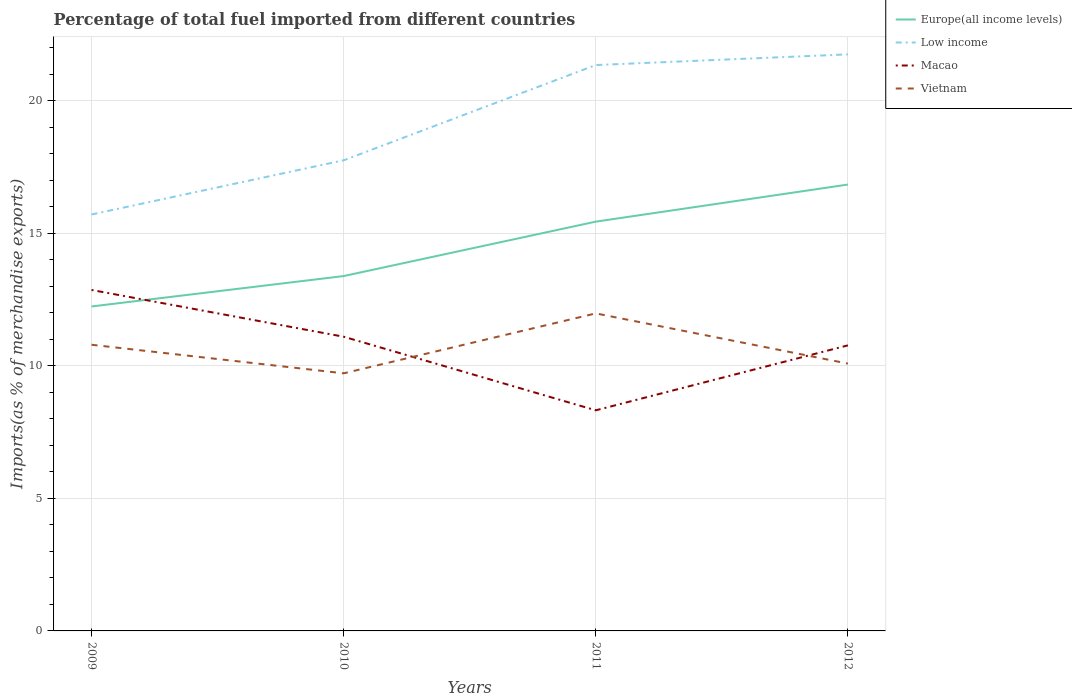Across all years, what is the maximum percentage of imports to different countries in Low income?
Provide a succinct answer. 15.72. What is the total percentage of imports to different countries in Europe(all income levels) in the graph?
Your response must be concise. -3.45. What is the difference between the highest and the second highest percentage of imports to different countries in Macao?
Provide a succinct answer. 4.54. What is the difference between the highest and the lowest percentage of imports to different countries in Vietnam?
Make the answer very short. 2. Is the percentage of imports to different countries in Macao strictly greater than the percentage of imports to different countries in Low income over the years?
Provide a short and direct response. Yes. Does the graph contain grids?
Make the answer very short. Yes. How many legend labels are there?
Give a very brief answer. 4. How are the legend labels stacked?
Make the answer very short. Vertical. What is the title of the graph?
Your response must be concise. Percentage of total fuel imported from different countries. What is the label or title of the Y-axis?
Keep it short and to the point. Imports(as % of merchandise exports). What is the Imports(as % of merchandise exports) of Europe(all income levels) in 2009?
Your answer should be very brief. 12.24. What is the Imports(as % of merchandise exports) of Low income in 2009?
Ensure brevity in your answer.  15.72. What is the Imports(as % of merchandise exports) of Macao in 2009?
Make the answer very short. 12.87. What is the Imports(as % of merchandise exports) in Vietnam in 2009?
Your answer should be compact. 10.8. What is the Imports(as % of merchandise exports) of Europe(all income levels) in 2010?
Provide a succinct answer. 13.39. What is the Imports(as % of merchandise exports) in Low income in 2010?
Your response must be concise. 17.76. What is the Imports(as % of merchandise exports) in Macao in 2010?
Offer a very short reply. 11.1. What is the Imports(as % of merchandise exports) of Vietnam in 2010?
Your response must be concise. 9.72. What is the Imports(as % of merchandise exports) of Europe(all income levels) in 2011?
Offer a terse response. 15.45. What is the Imports(as % of merchandise exports) in Low income in 2011?
Give a very brief answer. 21.36. What is the Imports(as % of merchandise exports) in Macao in 2011?
Ensure brevity in your answer.  8.33. What is the Imports(as % of merchandise exports) of Vietnam in 2011?
Keep it short and to the point. 11.98. What is the Imports(as % of merchandise exports) in Europe(all income levels) in 2012?
Offer a very short reply. 16.85. What is the Imports(as % of merchandise exports) of Low income in 2012?
Your response must be concise. 21.76. What is the Imports(as % of merchandise exports) of Macao in 2012?
Make the answer very short. 10.78. What is the Imports(as % of merchandise exports) of Vietnam in 2012?
Keep it short and to the point. 10.09. Across all years, what is the maximum Imports(as % of merchandise exports) in Europe(all income levels)?
Offer a terse response. 16.85. Across all years, what is the maximum Imports(as % of merchandise exports) of Low income?
Your answer should be compact. 21.76. Across all years, what is the maximum Imports(as % of merchandise exports) of Macao?
Offer a terse response. 12.87. Across all years, what is the maximum Imports(as % of merchandise exports) of Vietnam?
Make the answer very short. 11.98. Across all years, what is the minimum Imports(as % of merchandise exports) in Europe(all income levels)?
Provide a succinct answer. 12.24. Across all years, what is the minimum Imports(as % of merchandise exports) in Low income?
Provide a succinct answer. 15.72. Across all years, what is the minimum Imports(as % of merchandise exports) in Macao?
Give a very brief answer. 8.33. Across all years, what is the minimum Imports(as % of merchandise exports) in Vietnam?
Provide a succinct answer. 9.72. What is the total Imports(as % of merchandise exports) in Europe(all income levels) in the graph?
Ensure brevity in your answer.  57.93. What is the total Imports(as % of merchandise exports) in Low income in the graph?
Give a very brief answer. 76.59. What is the total Imports(as % of merchandise exports) in Macao in the graph?
Your answer should be very brief. 43.07. What is the total Imports(as % of merchandise exports) in Vietnam in the graph?
Provide a succinct answer. 42.59. What is the difference between the Imports(as % of merchandise exports) in Europe(all income levels) in 2009 and that in 2010?
Your response must be concise. -1.15. What is the difference between the Imports(as % of merchandise exports) in Low income in 2009 and that in 2010?
Provide a short and direct response. -2.04. What is the difference between the Imports(as % of merchandise exports) in Macao in 2009 and that in 2010?
Give a very brief answer. 1.76. What is the difference between the Imports(as % of merchandise exports) in Vietnam in 2009 and that in 2010?
Your answer should be very brief. 1.08. What is the difference between the Imports(as % of merchandise exports) of Europe(all income levels) in 2009 and that in 2011?
Offer a very short reply. -3.2. What is the difference between the Imports(as % of merchandise exports) in Low income in 2009 and that in 2011?
Give a very brief answer. -5.64. What is the difference between the Imports(as % of merchandise exports) in Macao in 2009 and that in 2011?
Provide a succinct answer. 4.54. What is the difference between the Imports(as % of merchandise exports) of Vietnam in 2009 and that in 2011?
Ensure brevity in your answer.  -1.18. What is the difference between the Imports(as % of merchandise exports) of Europe(all income levels) in 2009 and that in 2012?
Ensure brevity in your answer.  -4.6. What is the difference between the Imports(as % of merchandise exports) of Low income in 2009 and that in 2012?
Provide a short and direct response. -6.04. What is the difference between the Imports(as % of merchandise exports) of Macao in 2009 and that in 2012?
Your answer should be very brief. 2.09. What is the difference between the Imports(as % of merchandise exports) of Vietnam in 2009 and that in 2012?
Your response must be concise. 0.71. What is the difference between the Imports(as % of merchandise exports) of Europe(all income levels) in 2010 and that in 2011?
Make the answer very short. -2.05. What is the difference between the Imports(as % of merchandise exports) in Low income in 2010 and that in 2011?
Provide a short and direct response. -3.59. What is the difference between the Imports(as % of merchandise exports) of Macao in 2010 and that in 2011?
Provide a short and direct response. 2.78. What is the difference between the Imports(as % of merchandise exports) in Vietnam in 2010 and that in 2011?
Ensure brevity in your answer.  -2.26. What is the difference between the Imports(as % of merchandise exports) of Europe(all income levels) in 2010 and that in 2012?
Provide a succinct answer. -3.45. What is the difference between the Imports(as % of merchandise exports) in Low income in 2010 and that in 2012?
Give a very brief answer. -4. What is the difference between the Imports(as % of merchandise exports) of Macao in 2010 and that in 2012?
Your answer should be very brief. 0.33. What is the difference between the Imports(as % of merchandise exports) in Vietnam in 2010 and that in 2012?
Make the answer very short. -0.37. What is the difference between the Imports(as % of merchandise exports) in Europe(all income levels) in 2011 and that in 2012?
Provide a short and direct response. -1.4. What is the difference between the Imports(as % of merchandise exports) of Low income in 2011 and that in 2012?
Your answer should be very brief. -0.4. What is the difference between the Imports(as % of merchandise exports) of Macao in 2011 and that in 2012?
Give a very brief answer. -2.45. What is the difference between the Imports(as % of merchandise exports) of Vietnam in 2011 and that in 2012?
Provide a succinct answer. 1.89. What is the difference between the Imports(as % of merchandise exports) in Europe(all income levels) in 2009 and the Imports(as % of merchandise exports) in Low income in 2010?
Your answer should be compact. -5.52. What is the difference between the Imports(as % of merchandise exports) of Europe(all income levels) in 2009 and the Imports(as % of merchandise exports) of Macao in 2010?
Offer a terse response. 1.14. What is the difference between the Imports(as % of merchandise exports) in Europe(all income levels) in 2009 and the Imports(as % of merchandise exports) in Vietnam in 2010?
Offer a terse response. 2.52. What is the difference between the Imports(as % of merchandise exports) in Low income in 2009 and the Imports(as % of merchandise exports) in Macao in 2010?
Keep it short and to the point. 4.61. What is the difference between the Imports(as % of merchandise exports) of Low income in 2009 and the Imports(as % of merchandise exports) of Vietnam in 2010?
Provide a short and direct response. 5.99. What is the difference between the Imports(as % of merchandise exports) of Macao in 2009 and the Imports(as % of merchandise exports) of Vietnam in 2010?
Your answer should be very brief. 3.15. What is the difference between the Imports(as % of merchandise exports) in Europe(all income levels) in 2009 and the Imports(as % of merchandise exports) in Low income in 2011?
Make the answer very short. -9.11. What is the difference between the Imports(as % of merchandise exports) in Europe(all income levels) in 2009 and the Imports(as % of merchandise exports) in Macao in 2011?
Your answer should be very brief. 3.92. What is the difference between the Imports(as % of merchandise exports) in Europe(all income levels) in 2009 and the Imports(as % of merchandise exports) in Vietnam in 2011?
Your response must be concise. 0.26. What is the difference between the Imports(as % of merchandise exports) of Low income in 2009 and the Imports(as % of merchandise exports) of Macao in 2011?
Provide a short and direct response. 7.39. What is the difference between the Imports(as % of merchandise exports) of Low income in 2009 and the Imports(as % of merchandise exports) of Vietnam in 2011?
Your answer should be very brief. 3.73. What is the difference between the Imports(as % of merchandise exports) in Macao in 2009 and the Imports(as % of merchandise exports) in Vietnam in 2011?
Your answer should be compact. 0.88. What is the difference between the Imports(as % of merchandise exports) in Europe(all income levels) in 2009 and the Imports(as % of merchandise exports) in Low income in 2012?
Your answer should be very brief. -9.51. What is the difference between the Imports(as % of merchandise exports) in Europe(all income levels) in 2009 and the Imports(as % of merchandise exports) in Macao in 2012?
Offer a terse response. 1.47. What is the difference between the Imports(as % of merchandise exports) of Europe(all income levels) in 2009 and the Imports(as % of merchandise exports) of Vietnam in 2012?
Offer a very short reply. 2.16. What is the difference between the Imports(as % of merchandise exports) in Low income in 2009 and the Imports(as % of merchandise exports) in Macao in 2012?
Offer a terse response. 4.94. What is the difference between the Imports(as % of merchandise exports) in Low income in 2009 and the Imports(as % of merchandise exports) in Vietnam in 2012?
Ensure brevity in your answer.  5.63. What is the difference between the Imports(as % of merchandise exports) of Macao in 2009 and the Imports(as % of merchandise exports) of Vietnam in 2012?
Provide a succinct answer. 2.78. What is the difference between the Imports(as % of merchandise exports) in Europe(all income levels) in 2010 and the Imports(as % of merchandise exports) in Low income in 2011?
Your response must be concise. -7.96. What is the difference between the Imports(as % of merchandise exports) of Europe(all income levels) in 2010 and the Imports(as % of merchandise exports) of Macao in 2011?
Your response must be concise. 5.07. What is the difference between the Imports(as % of merchandise exports) in Europe(all income levels) in 2010 and the Imports(as % of merchandise exports) in Vietnam in 2011?
Provide a short and direct response. 1.41. What is the difference between the Imports(as % of merchandise exports) of Low income in 2010 and the Imports(as % of merchandise exports) of Macao in 2011?
Keep it short and to the point. 9.44. What is the difference between the Imports(as % of merchandise exports) in Low income in 2010 and the Imports(as % of merchandise exports) in Vietnam in 2011?
Provide a succinct answer. 5.78. What is the difference between the Imports(as % of merchandise exports) in Macao in 2010 and the Imports(as % of merchandise exports) in Vietnam in 2011?
Your response must be concise. -0.88. What is the difference between the Imports(as % of merchandise exports) of Europe(all income levels) in 2010 and the Imports(as % of merchandise exports) of Low income in 2012?
Keep it short and to the point. -8.37. What is the difference between the Imports(as % of merchandise exports) of Europe(all income levels) in 2010 and the Imports(as % of merchandise exports) of Macao in 2012?
Ensure brevity in your answer.  2.62. What is the difference between the Imports(as % of merchandise exports) in Europe(all income levels) in 2010 and the Imports(as % of merchandise exports) in Vietnam in 2012?
Make the answer very short. 3.3. What is the difference between the Imports(as % of merchandise exports) in Low income in 2010 and the Imports(as % of merchandise exports) in Macao in 2012?
Your response must be concise. 6.98. What is the difference between the Imports(as % of merchandise exports) of Low income in 2010 and the Imports(as % of merchandise exports) of Vietnam in 2012?
Your response must be concise. 7.67. What is the difference between the Imports(as % of merchandise exports) in Macao in 2010 and the Imports(as % of merchandise exports) in Vietnam in 2012?
Provide a succinct answer. 1.01. What is the difference between the Imports(as % of merchandise exports) in Europe(all income levels) in 2011 and the Imports(as % of merchandise exports) in Low income in 2012?
Your answer should be very brief. -6.31. What is the difference between the Imports(as % of merchandise exports) of Europe(all income levels) in 2011 and the Imports(as % of merchandise exports) of Macao in 2012?
Provide a short and direct response. 4.67. What is the difference between the Imports(as % of merchandise exports) of Europe(all income levels) in 2011 and the Imports(as % of merchandise exports) of Vietnam in 2012?
Your answer should be very brief. 5.36. What is the difference between the Imports(as % of merchandise exports) of Low income in 2011 and the Imports(as % of merchandise exports) of Macao in 2012?
Provide a succinct answer. 10.58. What is the difference between the Imports(as % of merchandise exports) of Low income in 2011 and the Imports(as % of merchandise exports) of Vietnam in 2012?
Provide a succinct answer. 11.27. What is the difference between the Imports(as % of merchandise exports) of Macao in 2011 and the Imports(as % of merchandise exports) of Vietnam in 2012?
Give a very brief answer. -1.76. What is the average Imports(as % of merchandise exports) in Europe(all income levels) per year?
Provide a succinct answer. 14.48. What is the average Imports(as % of merchandise exports) in Low income per year?
Ensure brevity in your answer.  19.15. What is the average Imports(as % of merchandise exports) of Macao per year?
Your answer should be very brief. 10.77. What is the average Imports(as % of merchandise exports) of Vietnam per year?
Ensure brevity in your answer.  10.65. In the year 2009, what is the difference between the Imports(as % of merchandise exports) in Europe(all income levels) and Imports(as % of merchandise exports) in Low income?
Provide a short and direct response. -3.47. In the year 2009, what is the difference between the Imports(as % of merchandise exports) in Europe(all income levels) and Imports(as % of merchandise exports) in Macao?
Offer a very short reply. -0.62. In the year 2009, what is the difference between the Imports(as % of merchandise exports) in Europe(all income levels) and Imports(as % of merchandise exports) in Vietnam?
Offer a very short reply. 1.45. In the year 2009, what is the difference between the Imports(as % of merchandise exports) of Low income and Imports(as % of merchandise exports) of Macao?
Ensure brevity in your answer.  2.85. In the year 2009, what is the difference between the Imports(as % of merchandise exports) in Low income and Imports(as % of merchandise exports) in Vietnam?
Keep it short and to the point. 4.92. In the year 2009, what is the difference between the Imports(as % of merchandise exports) of Macao and Imports(as % of merchandise exports) of Vietnam?
Offer a terse response. 2.07. In the year 2010, what is the difference between the Imports(as % of merchandise exports) in Europe(all income levels) and Imports(as % of merchandise exports) in Low income?
Keep it short and to the point. -4.37. In the year 2010, what is the difference between the Imports(as % of merchandise exports) in Europe(all income levels) and Imports(as % of merchandise exports) in Macao?
Offer a very short reply. 2.29. In the year 2010, what is the difference between the Imports(as % of merchandise exports) in Europe(all income levels) and Imports(as % of merchandise exports) in Vietnam?
Offer a very short reply. 3.67. In the year 2010, what is the difference between the Imports(as % of merchandise exports) of Low income and Imports(as % of merchandise exports) of Macao?
Make the answer very short. 6.66. In the year 2010, what is the difference between the Imports(as % of merchandise exports) in Low income and Imports(as % of merchandise exports) in Vietnam?
Give a very brief answer. 8.04. In the year 2010, what is the difference between the Imports(as % of merchandise exports) in Macao and Imports(as % of merchandise exports) in Vietnam?
Ensure brevity in your answer.  1.38. In the year 2011, what is the difference between the Imports(as % of merchandise exports) of Europe(all income levels) and Imports(as % of merchandise exports) of Low income?
Provide a short and direct response. -5.91. In the year 2011, what is the difference between the Imports(as % of merchandise exports) in Europe(all income levels) and Imports(as % of merchandise exports) in Macao?
Your response must be concise. 7.12. In the year 2011, what is the difference between the Imports(as % of merchandise exports) of Europe(all income levels) and Imports(as % of merchandise exports) of Vietnam?
Provide a succinct answer. 3.46. In the year 2011, what is the difference between the Imports(as % of merchandise exports) of Low income and Imports(as % of merchandise exports) of Macao?
Keep it short and to the point. 13.03. In the year 2011, what is the difference between the Imports(as % of merchandise exports) in Low income and Imports(as % of merchandise exports) in Vietnam?
Make the answer very short. 9.37. In the year 2011, what is the difference between the Imports(as % of merchandise exports) of Macao and Imports(as % of merchandise exports) of Vietnam?
Ensure brevity in your answer.  -3.66. In the year 2012, what is the difference between the Imports(as % of merchandise exports) of Europe(all income levels) and Imports(as % of merchandise exports) of Low income?
Provide a succinct answer. -4.91. In the year 2012, what is the difference between the Imports(as % of merchandise exports) of Europe(all income levels) and Imports(as % of merchandise exports) of Macao?
Your answer should be compact. 6.07. In the year 2012, what is the difference between the Imports(as % of merchandise exports) of Europe(all income levels) and Imports(as % of merchandise exports) of Vietnam?
Ensure brevity in your answer.  6.76. In the year 2012, what is the difference between the Imports(as % of merchandise exports) in Low income and Imports(as % of merchandise exports) in Macao?
Offer a terse response. 10.98. In the year 2012, what is the difference between the Imports(as % of merchandise exports) in Low income and Imports(as % of merchandise exports) in Vietnam?
Your answer should be very brief. 11.67. In the year 2012, what is the difference between the Imports(as % of merchandise exports) of Macao and Imports(as % of merchandise exports) of Vietnam?
Your answer should be very brief. 0.69. What is the ratio of the Imports(as % of merchandise exports) of Europe(all income levels) in 2009 to that in 2010?
Your response must be concise. 0.91. What is the ratio of the Imports(as % of merchandise exports) in Low income in 2009 to that in 2010?
Provide a short and direct response. 0.88. What is the ratio of the Imports(as % of merchandise exports) of Macao in 2009 to that in 2010?
Your answer should be compact. 1.16. What is the ratio of the Imports(as % of merchandise exports) of Vietnam in 2009 to that in 2010?
Your response must be concise. 1.11. What is the ratio of the Imports(as % of merchandise exports) of Europe(all income levels) in 2009 to that in 2011?
Offer a very short reply. 0.79. What is the ratio of the Imports(as % of merchandise exports) of Low income in 2009 to that in 2011?
Offer a terse response. 0.74. What is the ratio of the Imports(as % of merchandise exports) in Macao in 2009 to that in 2011?
Your answer should be compact. 1.55. What is the ratio of the Imports(as % of merchandise exports) in Vietnam in 2009 to that in 2011?
Your answer should be very brief. 0.9. What is the ratio of the Imports(as % of merchandise exports) in Europe(all income levels) in 2009 to that in 2012?
Offer a very short reply. 0.73. What is the ratio of the Imports(as % of merchandise exports) in Low income in 2009 to that in 2012?
Your answer should be compact. 0.72. What is the ratio of the Imports(as % of merchandise exports) in Macao in 2009 to that in 2012?
Provide a succinct answer. 1.19. What is the ratio of the Imports(as % of merchandise exports) of Vietnam in 2009 to that in 2012?
Give a very brief answer. 1.07. What is the ratio of the Imports(as % of merchandise exports) in Europe(all income levels) in 2010 to that in 2011?
Ensure brevity in your answer.  0.87. What is the ratio of the Imports(as % of merchandise exports) in Low income in 2010 to that in 2011?
Give a very brief answer. 0.83. What is the ratio of the Imports(as % of merchandise exports) of Macao in 2010 to that in 2011?
Your answer should be very brief. 1.33. What is the ratio of the Imports(as % of merchandise exports) in Vietnam in 2010 to that in 2011?
Your answer should be very brief. 0.81. What is the ratio of the Imports(as % of merchandise exports) of Europe(all income levels) in 2010 to that in 2012?
Ensure brevity in your answer.  0.8. What is the ratio of the Imports(as % of merchandise exports) of Low income in 2010 to that in 2012?
Keep it short and to the point. 0.82. What is the ratio of the Imports(as % of merchandise exports) in Macao in 2010 to that in 2012?
Offer a terse response. 1.03. What is the ratio of the Imports(as % of merchandise exports) of Vietnam in 2010 to that in 2012?
Your response must be concise. 0.96. What is the ratio of the Imports(as % of merchandise exports) in Europe(all income levels) in 2011 to that in 2012?
Offer a very short reply. 0.92. What is the ratio of the Imports(as % of merchandise exports) in Low income in 2011 to that in 2012?
Keep it short and to the point. 0.98. What is the ratio of the Imports(as % of merchandise exports) of Macao in 2011 to that in 2012?
Your response must be concise. 0.77. What is the ratio of the Imports(as % of merchandise exports) of Vietnam in 2011 to that in 2012?
Keep it short and to the point. 1.19. What is the difference between the highest and the second highest Imports(as % of merchandise exports) of Europe(all income levels)?
Provide a short and direct response. 1.4. What is the difference between the highest and the second highest Imports(as % of merchandise exports) of Low income?
Your response must be concise. 0.4. What is the difference between the highest and the second highest Imports(as % of merchandise exports) of Macao?
Make the answer very short. 1.76. What is the difference between the highest and the second highest Imports(as % of merchandise exports) in Vietnam?
Ensure brevity in your answer.  1.18. What is the difference between the highest and the lowest Imports(as % of merchandise exports) in Europe(all income levels)?
Your answer should be very brief. 4.6. What is the difference between the highest and the lowest Imports(as % of merchandise exports) of Low income?
Your response must be concise. 6.04. What is the difference between the highest and the lowest Imports(as % of merchandise exports) in Macao?
Your answer should be very brief. 4.54. What is the difference between the highest and the lowest Imports(as % of merchandise exports) in Vietnam?
Your answer should be very brief. 2.26. 